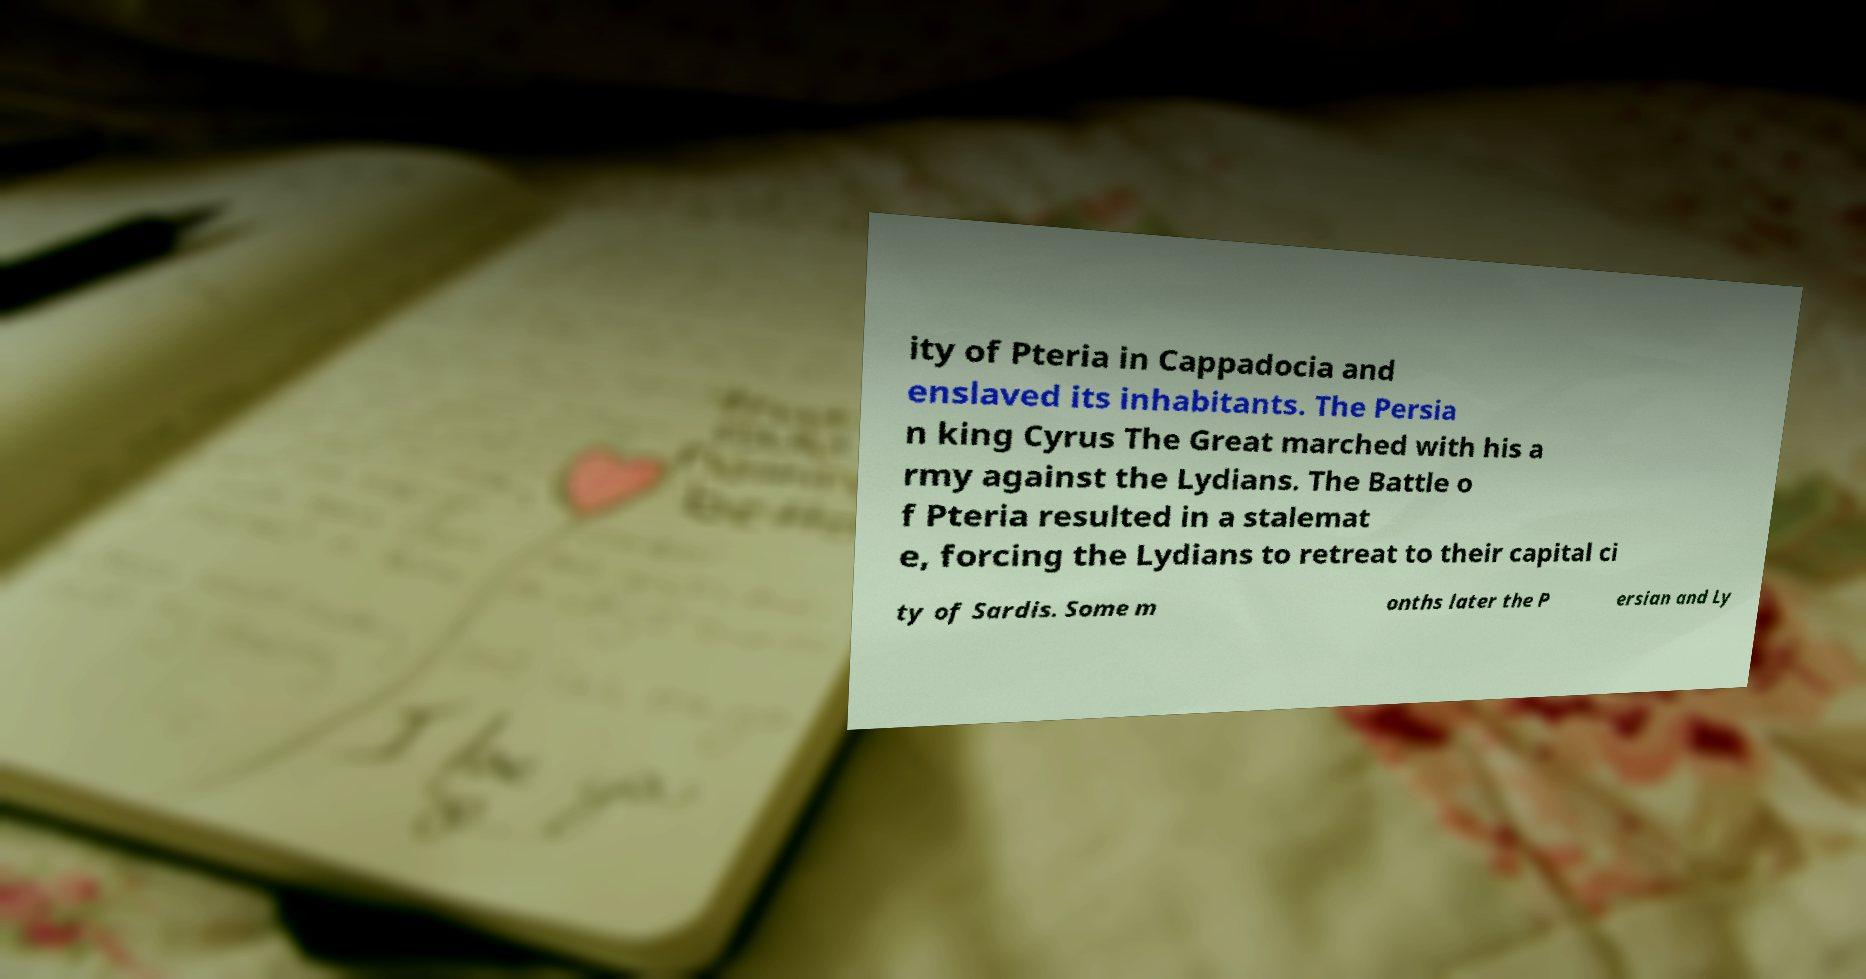What messages or text are displayed in this image? I need them in a readable, typed format. ity of Pteria in Cappadocia and enslaved its inhabitants. The Persia n king Cyrus The Great marched with his a rmy against the Lydians. The Battle o f Pteria resulted in a stalemat e, forcing the Lydians to retreat to their capital ci ty of Sardis. Some m onths later the P ersian and Ly 